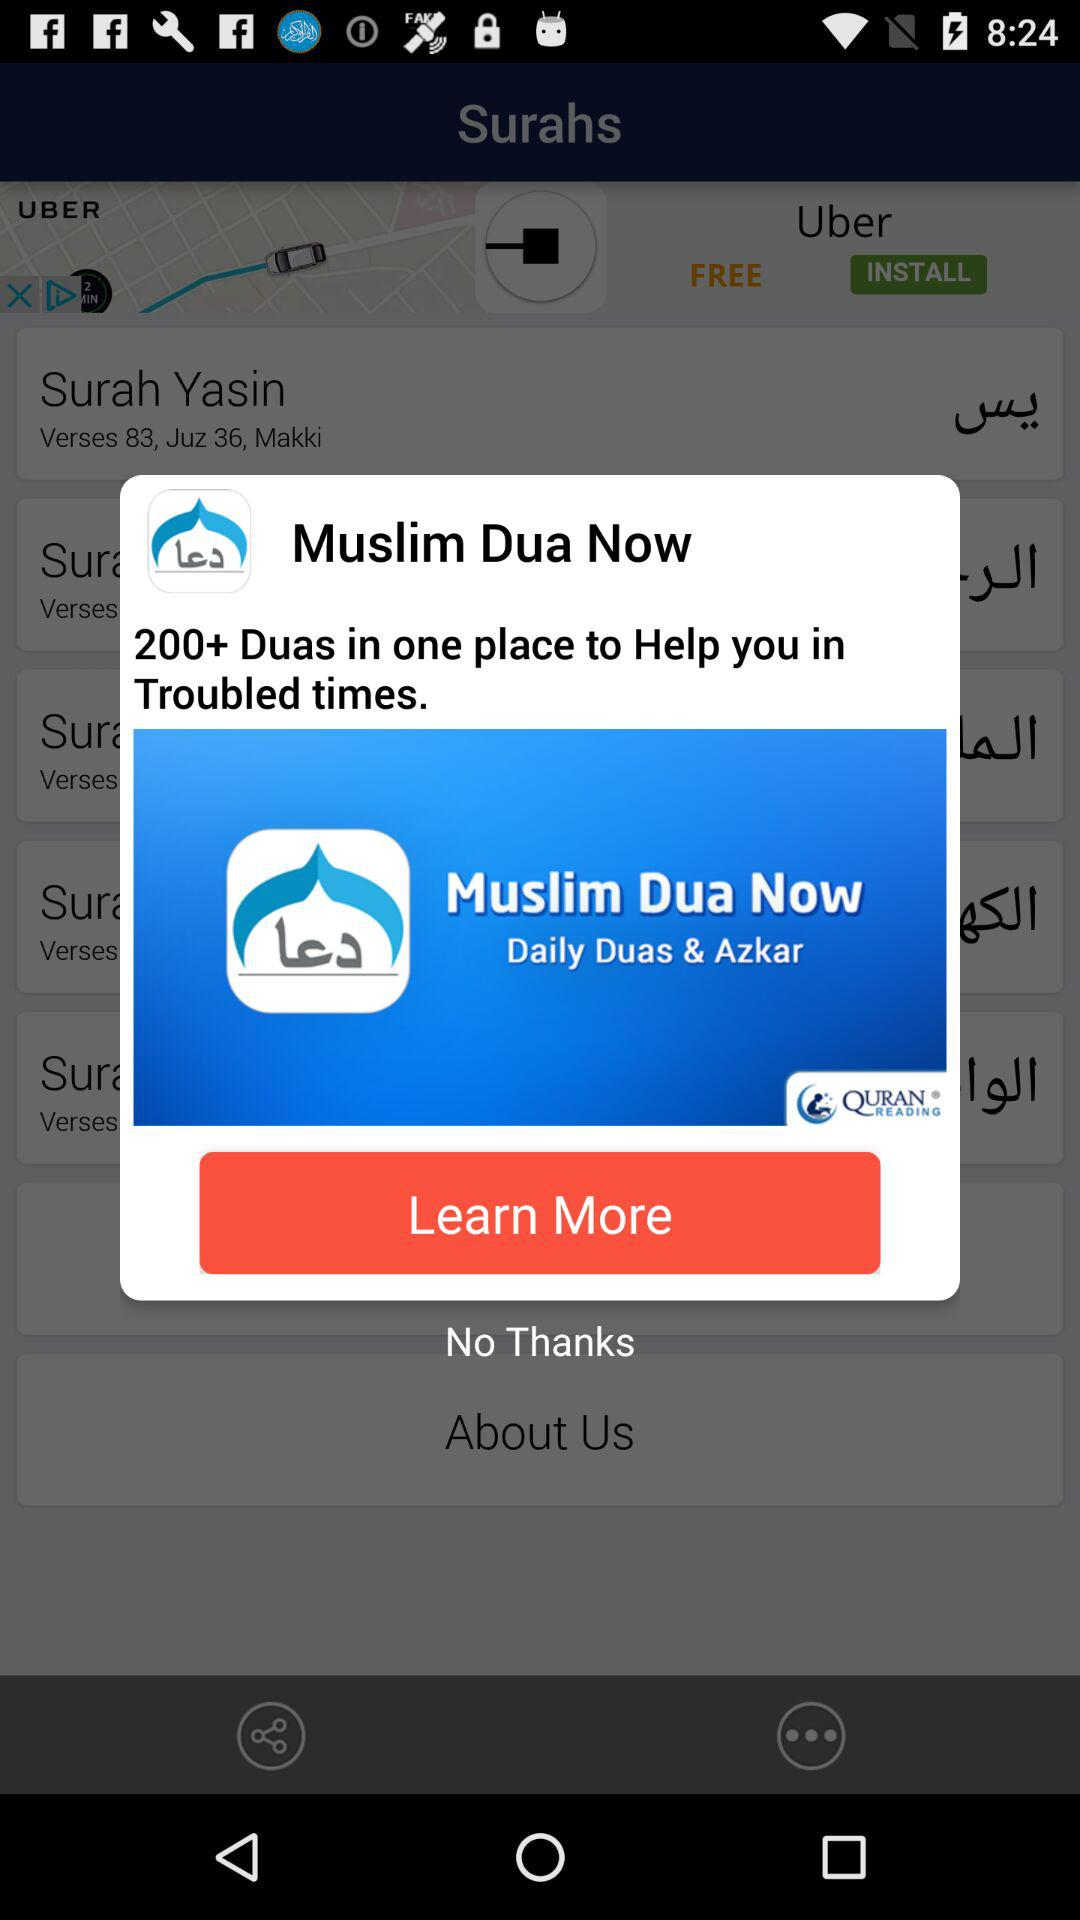How much does "Muslim Dua Now" cost?
When the provided information is insufficient, respond with <no answer>. <no answer> 